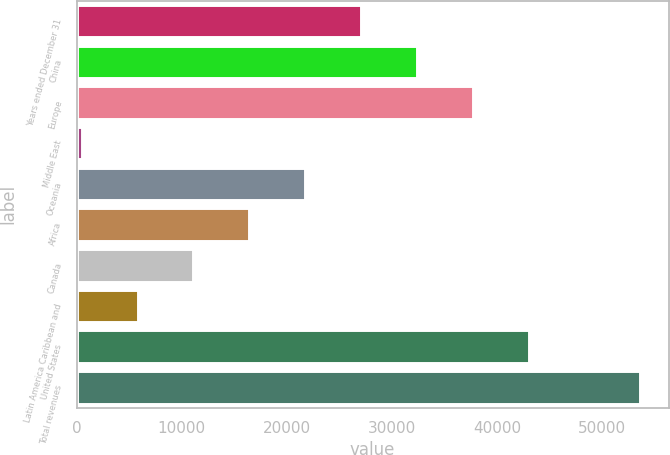<chart> <loc_0><loc_0><loc_500><loc_500><bar_chart><fcel>Years ended December 31<fcel>China<fcel>Europe<fcel>Middle East<fcel>Oceania<fcel>Africa<fcel>Canada<fcel>Latin America Caribbean and<fcel>United States<fcel>Total revenues<nl><fcel>27049<fcel>32363.4<fcel>37677.8<fcel>477<fcel>21734.6<fcel>16420.2<fcel>11105.8<fcel>5791.4<fcel>42992.2<fcel>53621<nl></chart> 